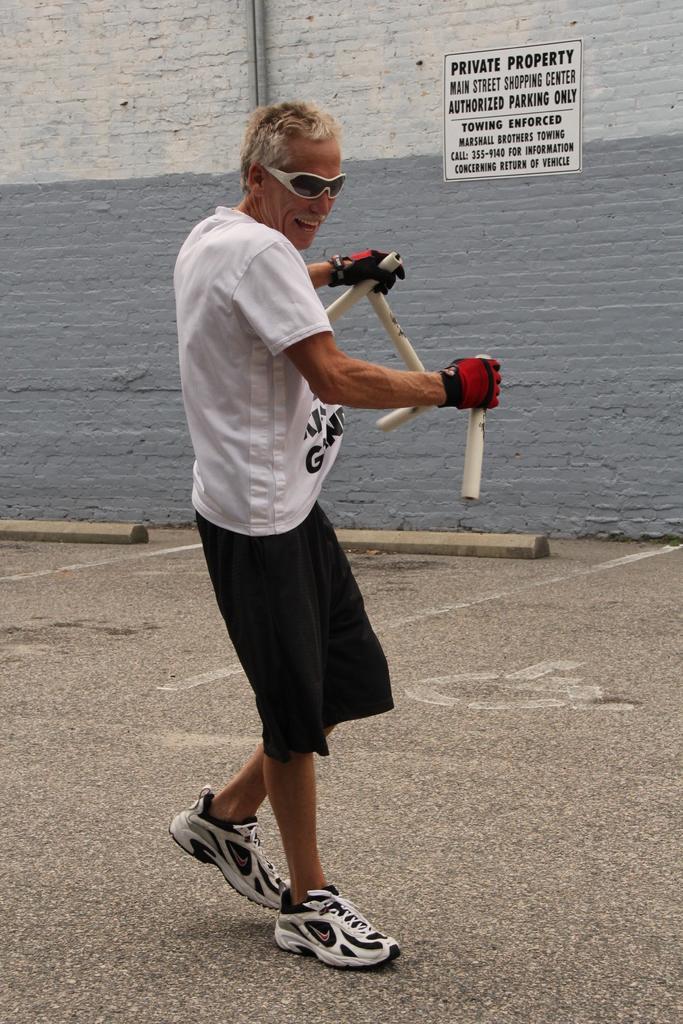Please provide a concise description of this image. In the middle of this image, there is a person in a white color T-shirt, holding sticks with both hands and on the road. In the background, there is a poster pasted on the wall, which is painted with gray and white color. On this wall, there are two pipes attached. Beside this wall, there are two poles placed on the road. 